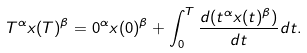Convert formula to latex. <formula><loc_0><loc_0><loc_500><loc_500>T ^ { \alpha } x ( T ) ^ { \beta } = 0 ^ { \alpha } x ( 0 ) ^ { \beta } + \int _ { 0 } ^ { T } \frac { d ( t ^ { \alpha } x ( t ) ^ { \beta } ) } { d t } d t .</formula> 